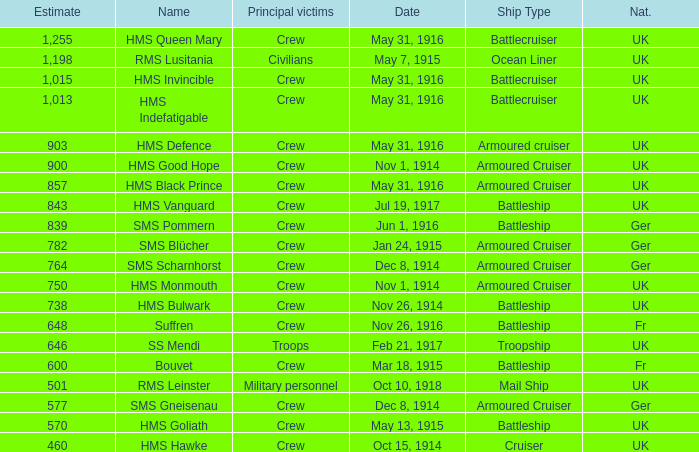What is the nationality of the ship when the principle victims are civilians? UK. 